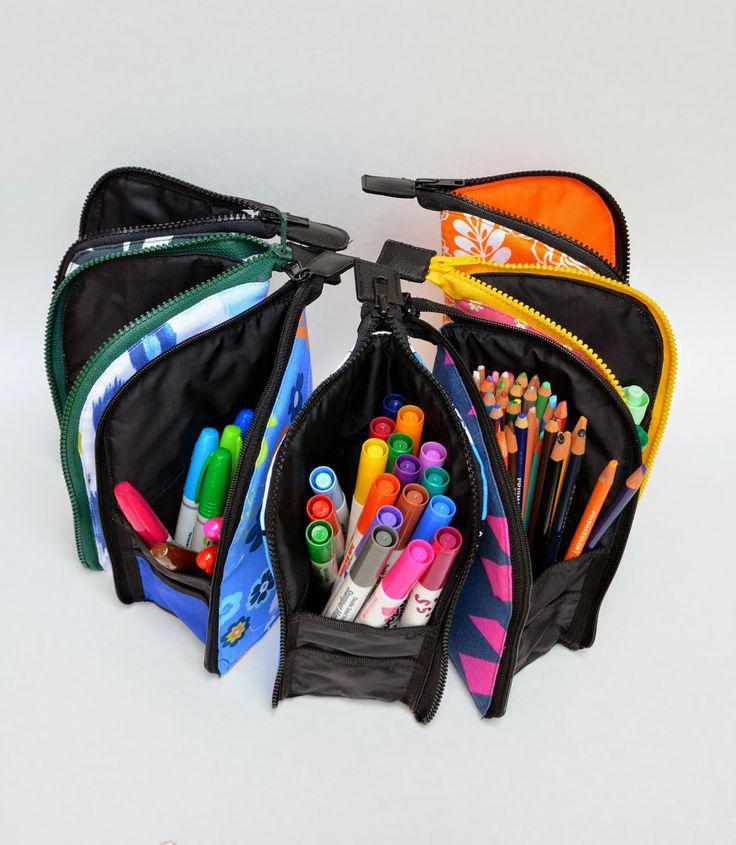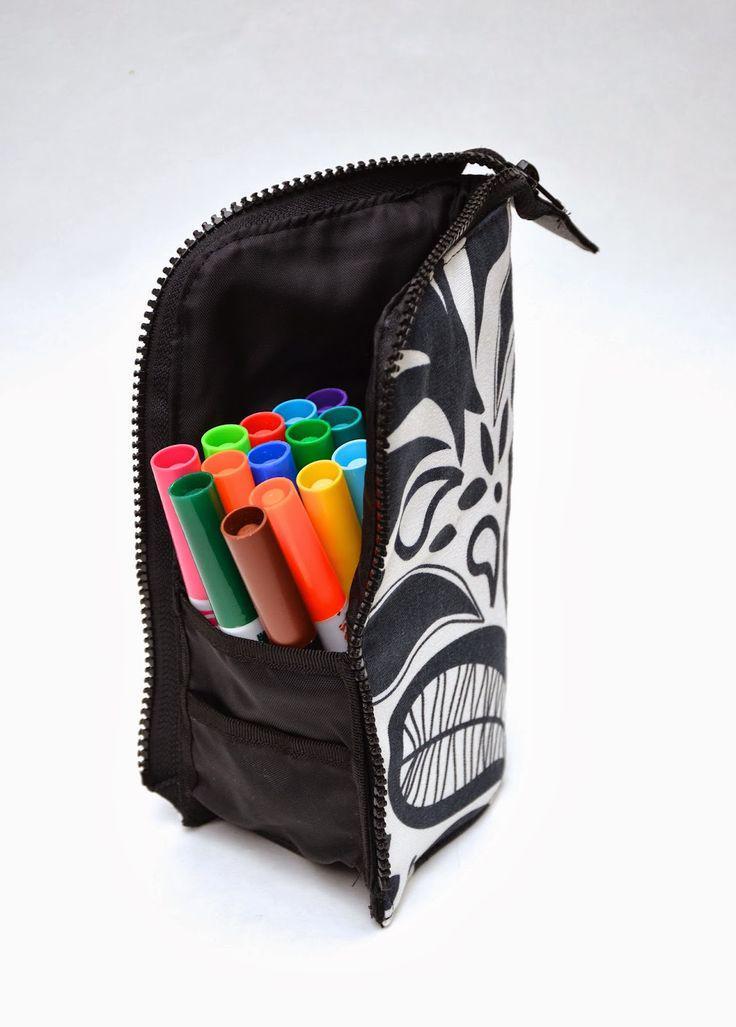The first image is the image on the left, the second image is the image on the right. Considering the images on both sides, is "There are two pencil holders in the pair of images." valid? Answer yes or no. No. The first image is the image on the left, the second image is the image on the right. Examine the images to the left and right. Is the description "An image shows an upright pencil pouch with a patterned exterior, filled with only upright colored-lead pencils." accurate? Answer yes or no. No. 